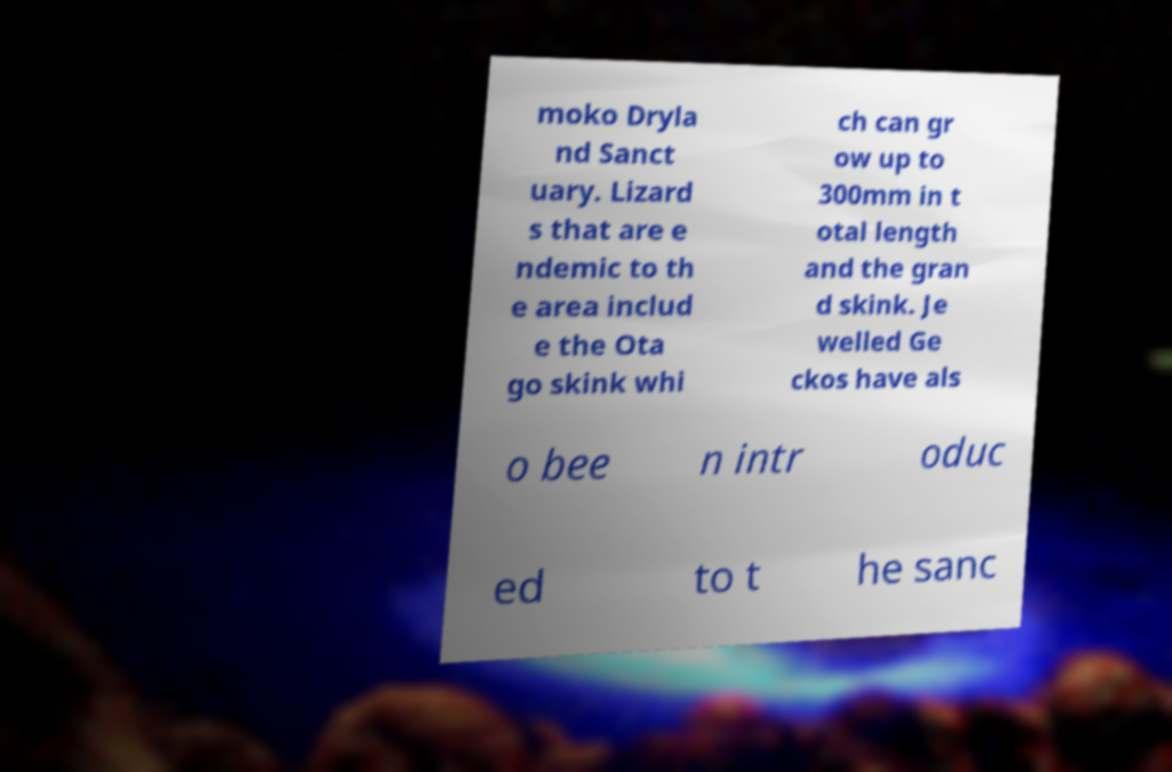For documentation purposes, I need the text within this image transcribed. Could you provide that? moko Dryla nd Sanct uary. Lizard s that are e ndemic to th e area includ e the Ota go skink whi ch can gr ow up to 300mm in t otal length and the gran d skink. Je welled Ge ckos have als o bee n intr oduc ed to t he sanc 